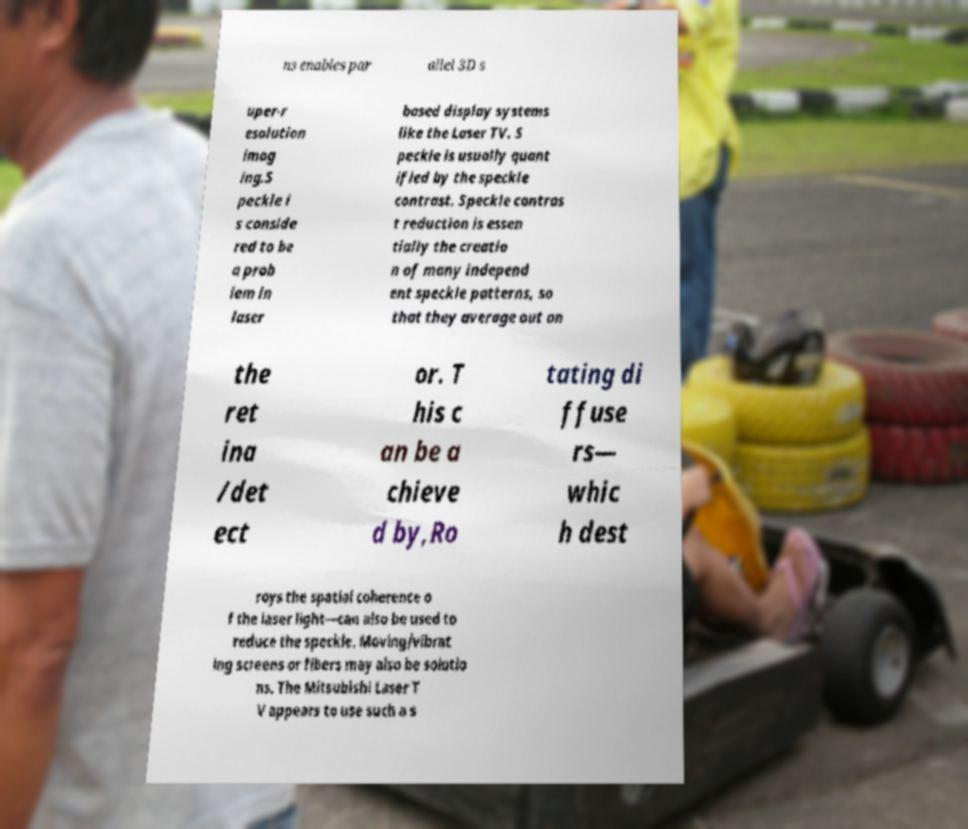Can you read and provide the text displayed in the image?This photo seems to have some interesting text. Can you extract and type it out for me? ns enables par allel 3D s uper-r esolution imag ing.S peckle i s conside red to be a prob lem in laser based display systems like the Laser TV. S peckle is usually quant ified by the speckle contrast. Speckle contras t reduction is essen tially the creatio n of many independ ent speckle patterns, so that they average out on the ret ina /det ect or. T his c an be a chieve d by,Ro tating di ffuse rs— whic h dest roys the spatial coherence o f the laser light—can also be used to reduce the speckle. Moving/vibrat ing screens or fibers may also be solutio ns. The Mitsubishi Laser T V appears to use such a s 